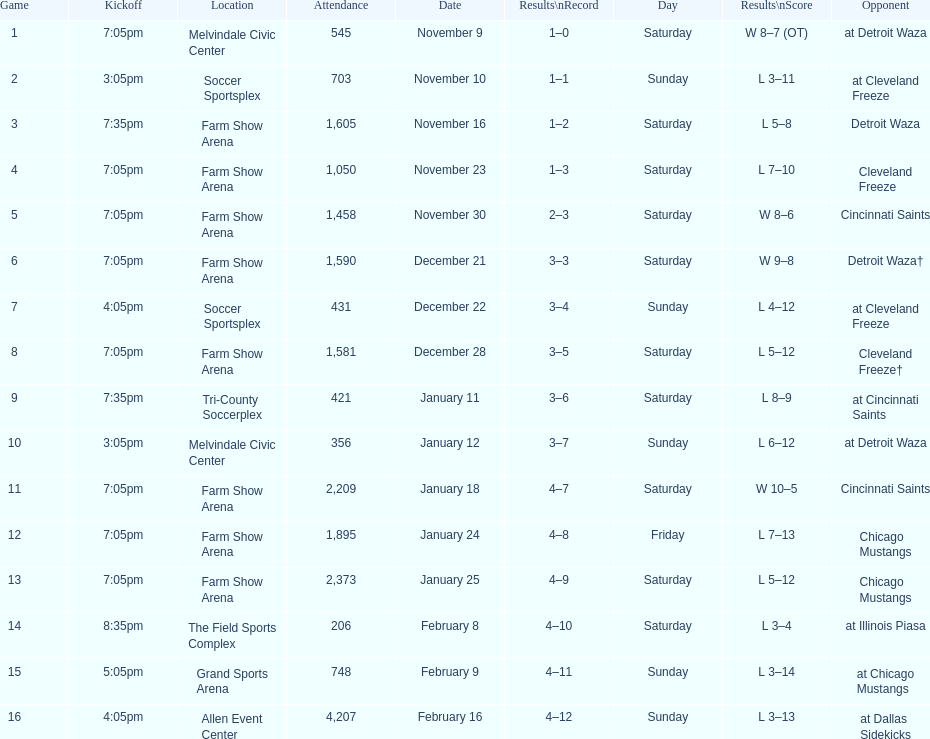Which opponent is listed first in the table? Detroit Waza. 